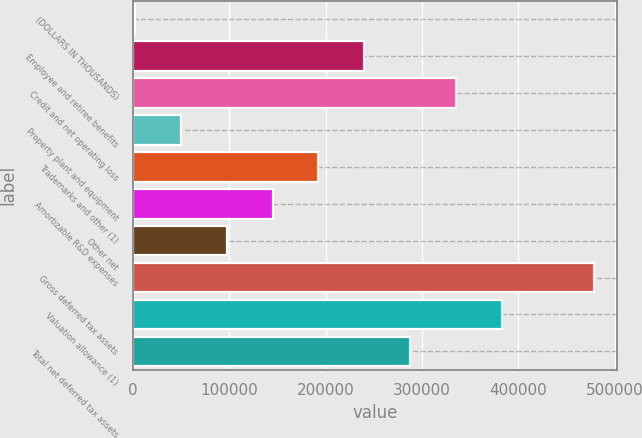<chart> <loc_0><loc_0><loc_500><loc_500><bar_chart><fcel>(DOLLARS IN THOUSANDS)<fcel>Employee and retiree benefits<fcel>Credit and net operating loss<fcel>Property plant and equipment<fcel>Trademarks and other (1)<fcel>Amortizable R&D expenses<fcel>Other net<fcel>Gross deferred tax assets<fcel>Valuation allowance (1)<fcel>Total net deferred tax assets<nl><fcel>2011<fcel>240166<fcel>335429<fcel>49642.1<fcel>192535<fcel>144904<fcel>97273.2<fcel>478322<fcel>383060<fcel>287798<nl></chart> 